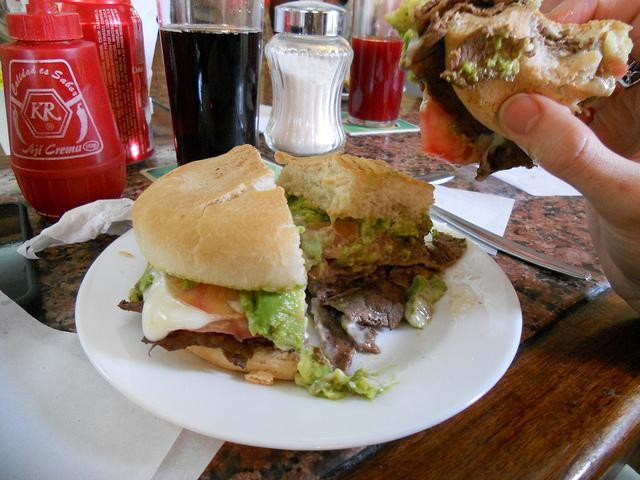What is she doing with the sandwich? eating 